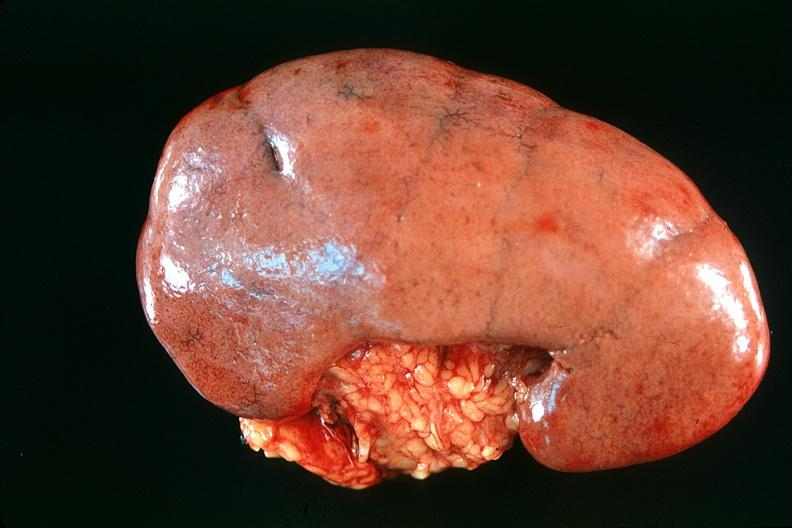where is this?
Answer the question using a single word or phrase. Urinary 